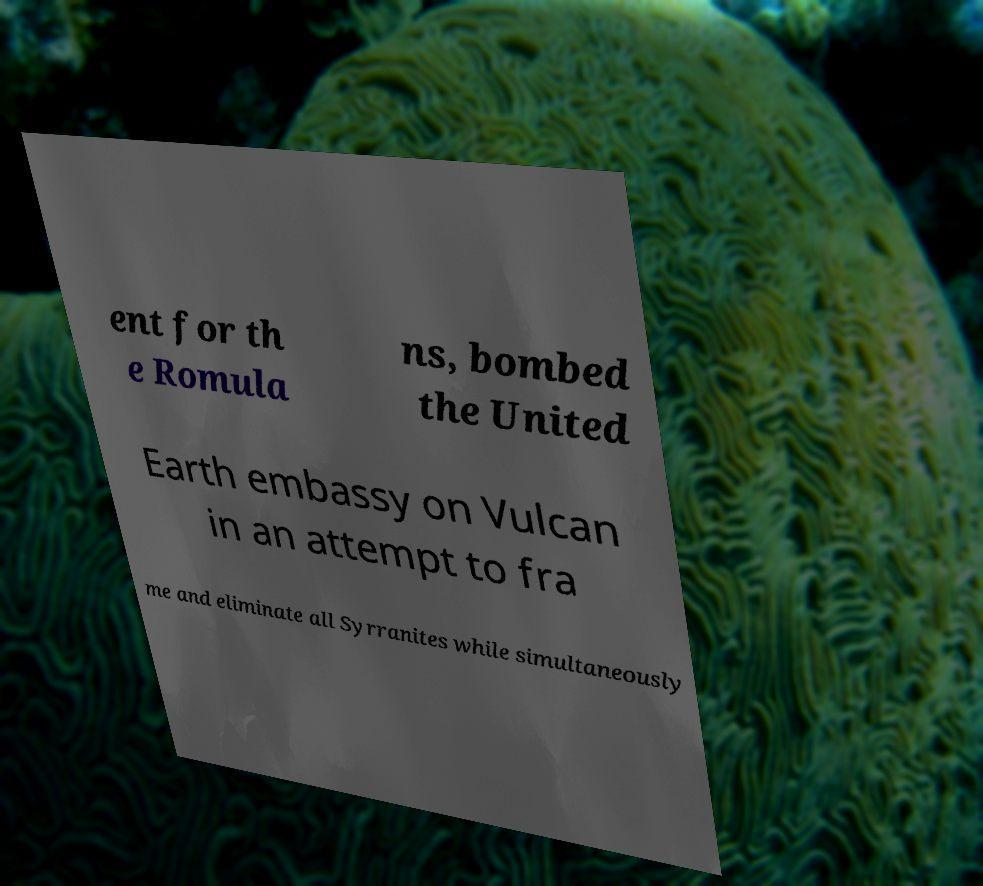Could you extract and type out the text from this image? ent for th e Romula ns, bombed the United Earth embassy on Vulcan in an attempt to fra me and eliminate all Syrranites while simultaneously 